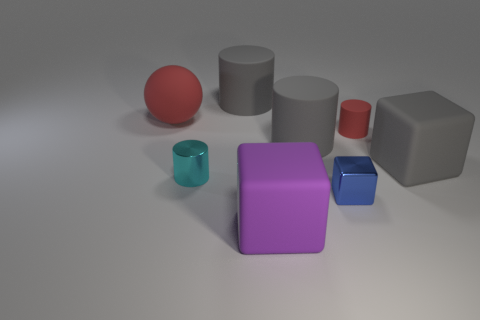There is a ball that is the same color as the tiny matte thing; what is its material?
Offer a terse response. Rubber. Are there any other tiny yellow blocks that have the same material as the tiny cube?
Keep it short and to the point. No. There is a red thing that is to the right of the rubber ball; does it have the same size as the purple thing?
Offer a very short reply. No. There is a big matte cube behind the big object in front of the gray cube; is there a tiny blue cube that is in front of it?
Give a very brief answer. Yes. What number of rubber objects are small blue objects or tiny red objects?
Provide a succinct answer. 1. What number of other objects are there of the same shape as the large purple thing?
Provide a succinct answer. 2. Are there more metal spheres than tiny matte cylinders?
Make the answer very short. No. What size is the block that is behind the small cyan cylinder that is to the left of the big thing in front of the large gray block?
Offer a terse response. Large. What is the size of the red thing right of the blue object?
Offer a very short reply. Small. What number of things are either large purple cubes or red matte objects that are on the left side of the tiny shiny cylinder?
Your response must be concise. 2. 